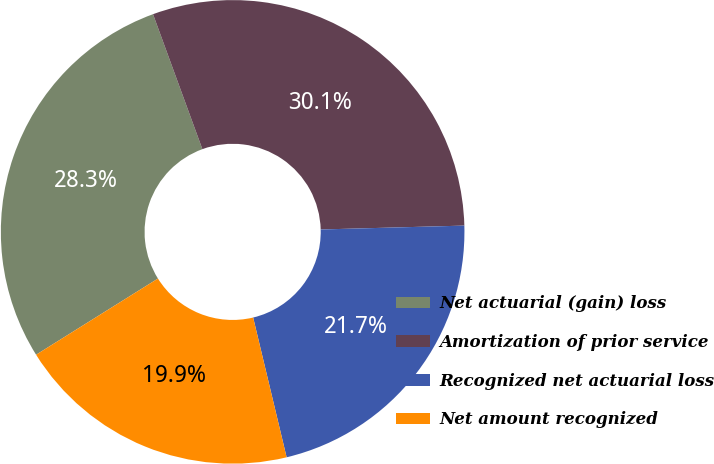Convert chart. <chart><loc_0><loc_0><loc_500><loc_500><pie_chart><fcel>Net actuarial (gain) loss<fcel>Amortization of prior service<fcel>Recognized net actuarial loss<fcel>Net amount recognized<nl><fcel>28.31%<fcel>30.15%<fcel>21.69%<fcel>19.85%<nl></chart> 